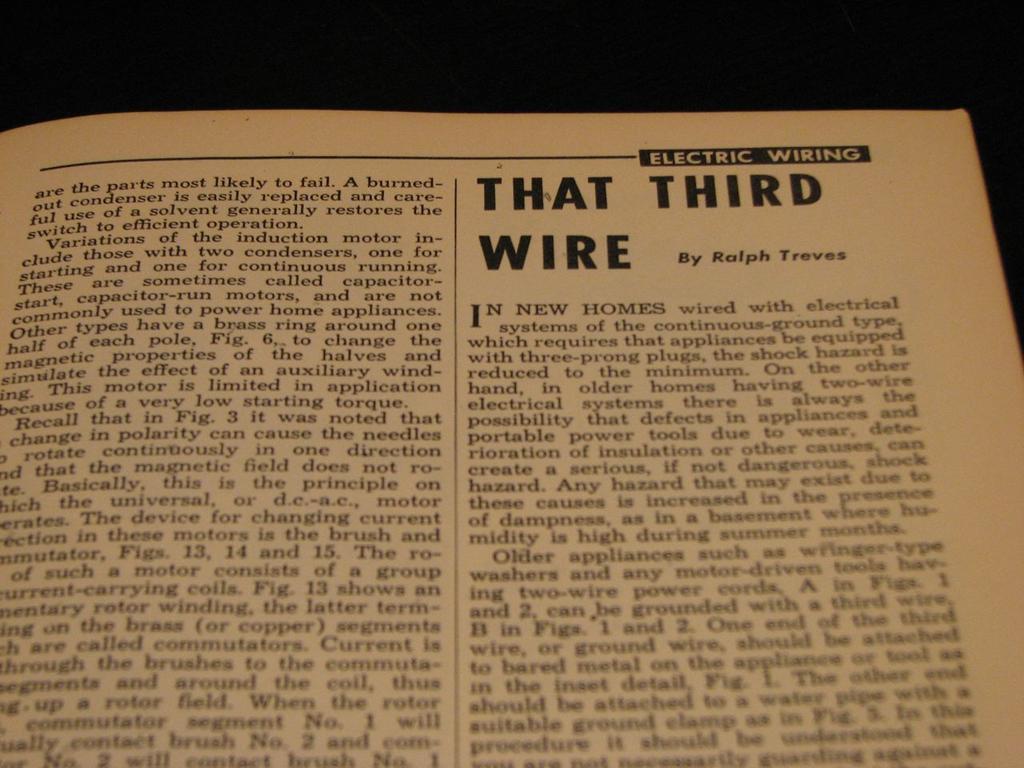What is the book title?
Keep it short and to the point. That third wire. How many wires are required for most appliances?
Keep it short and to the point. Three. 